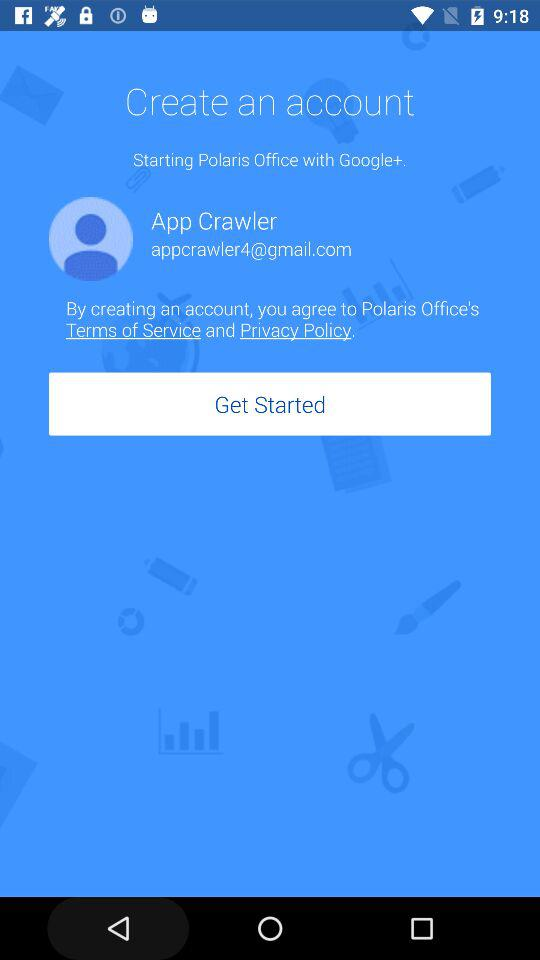What is the email address of the user? The email address is "appcrawler4@gmail.com". 